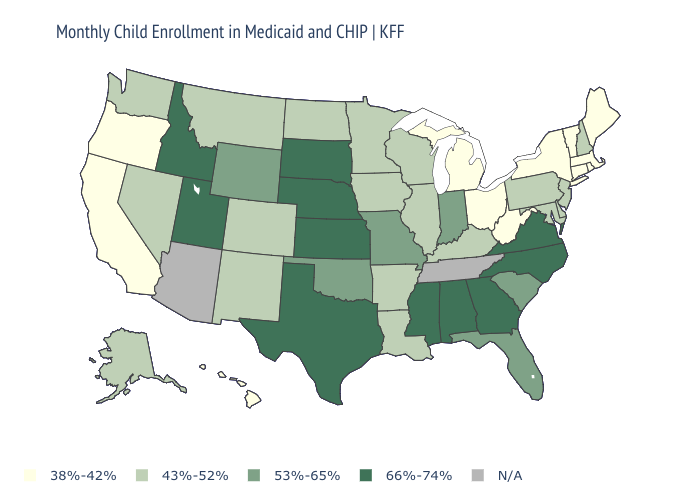What is the value of Missouri?
Answer briefly. 53%-65%. Name the states that have a value in the range N/A?
Short answer required. Arizona, Tennessee. Does Kansas have the highest value in the USA?
Be succinct. Yes. What is the value of Oklahoma?
Keep it brief. 53%-65%. What is the value of Wyoming?
Answer briefly. 53%-65%. Name the states that have a value in the range 53%-65%?
Quick response, please. Florida, Indiana, Missouri, Oklahoma, South Carolina, Wyoming. Name the states that have a value in the range 43%-52%?
Be succinct. Alaska, Arkansas, Colorado, Delaware, Illinois, Iowa, Kentucky, Louisiana, Maryland, Minnesota, Montana, Nevada, New Hampshire, New Jersey, New Mexico, North Dakota, Pennsylvania, Washington, Wisconsin. Among the states that border Iowa , does Nebraska have the lowest value?
Short answer required. No. What is the value of Wyoming?
Be succinct. 53%-65%. What is the value of Missouri?
Quick response, please. 53%-65%. Does the map have missing data?
Concise answer only. Yes. What is the highest value in the USA?
Be succinct. 66%-74%. What is the value of Ohio?
Give a very brief answer. 38%-42%. Does Virginia have the lowest value in the South?
Answer briefly. No. 